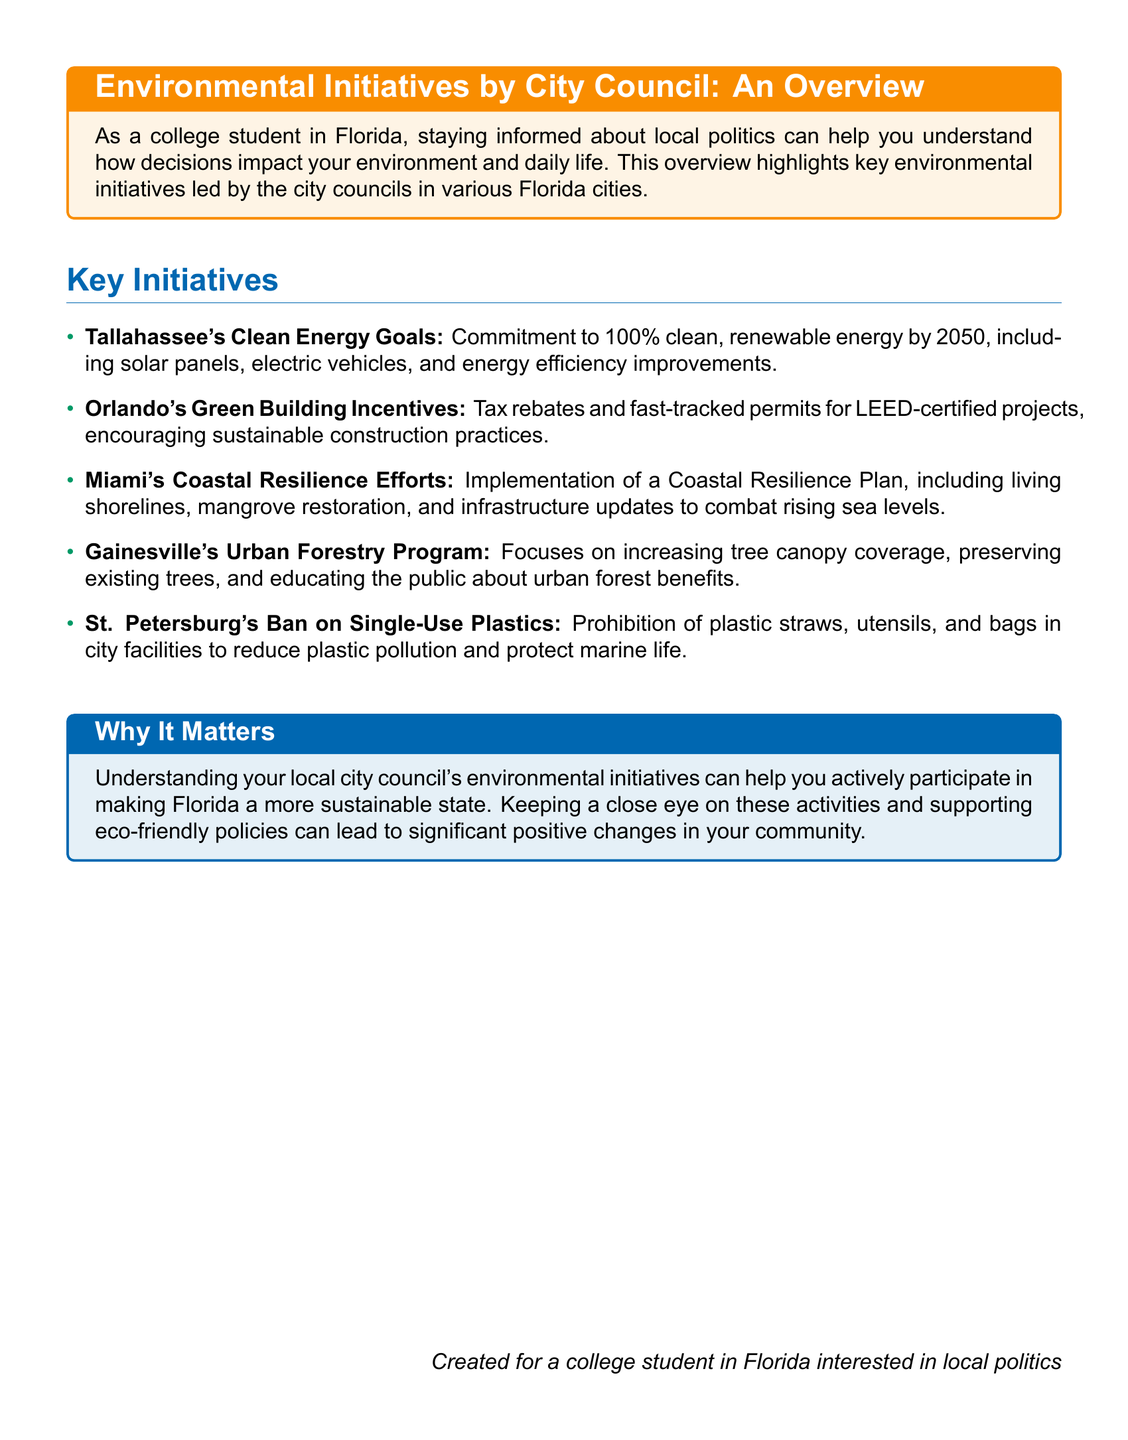What is Tallahassee's energy goal? Tallahassee aims for 100% clean, renewable energy by 2050.
Answer: 100% clean, renewable energy by 2050 What are Orlando's incentives for green building? Orlando offers tax rebates and fast-tracked permits for LEED-certified projects.
Answer: Tax rebates and fast-tracked permits What is the focus of Gainesville's Urban Forestry Program? Gainesville's program focuses on increasing tree canopy coverage and preserving existing trees.
Answer: Increasing tree canopy coverage What does St. Petersburg prohibit to protect marine life? St. Petersburg has a ban on single-use plastics, including straws and bags.
Answer: Ban on single-use plastics What is included in Miami's Coastal Resilience Plan? Miami's plan includes living shorelines, mangrove restoration, and infrastructure updates.
Answer: Living shorelines, mangrove restoration How might local initiatives impact a college student? Understanding these initiatives can help students participate in making Florida more sustainable.
Answer: Participate in making Florida more sustainable What type of document is this overview? The document is an overview that highlights environmental initiatives by city councils.
Answer: Overview of environmental initiatives What is the significance of tracking these initiatives? Tracking these initiatives can lead to significant positive changes in the community.
Answer: Significant positive changes in the community What color represents the title in this document? The title is represented in Florida blue color.
Answer: Florida blue 